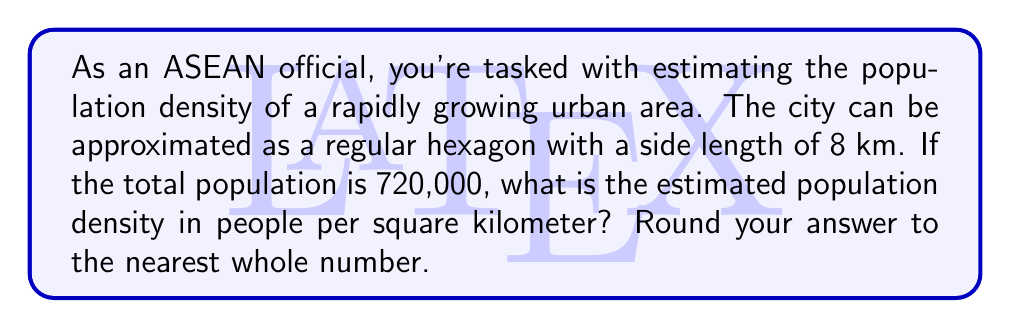Help me with this question. Let's approach this step-by-step:

1) First, we need to calculate the area of the hexagonal city. The formula for the area of a regular hexagon is:

   $$A = \frac{3\sqrt{3}}{2}s^2$$

   where $s$ is the side length.

2) Substituting $s = 8$ km:

   $$A = \frac{3\sqrt{3}}{2}(8^2) = 12\sqrt{3} \cdot 8 = 96\sqrt{3}$$ km²

3) Simplify:
   
   $$96\sqrt{3} \approx 166.2767$$ km²

4) Now, we can calculate the population density by dividing the total population by the area:

   Population Density = Total Population / Area

   $$\text{Density} = \frac{720,000}{166.2767}$$ people/km²

5) Calculate:

   $$\text{Density} \approx 4,329.8$$ people/km²

6) Rounding to the nearest whole number:

   Population Density ≈ 4,330 people/km²
Answer: 4,330 people/km² 